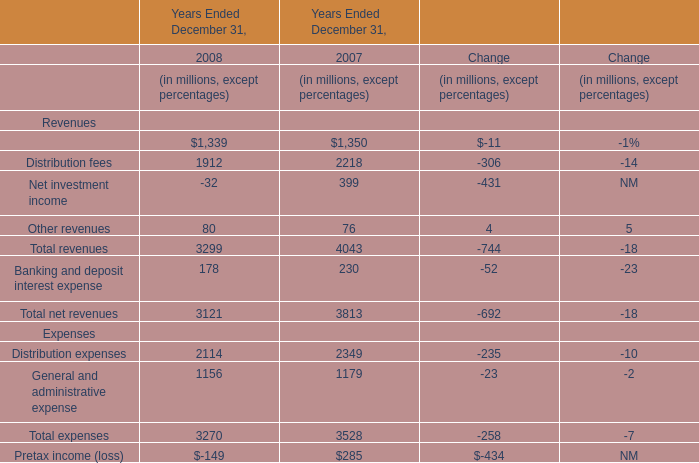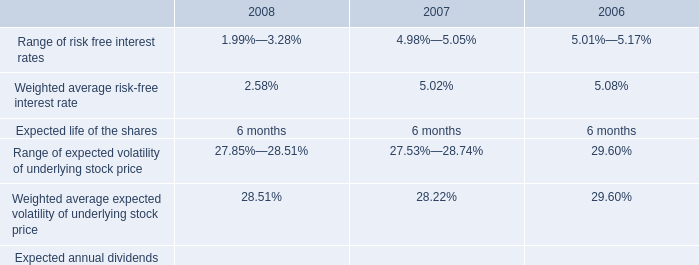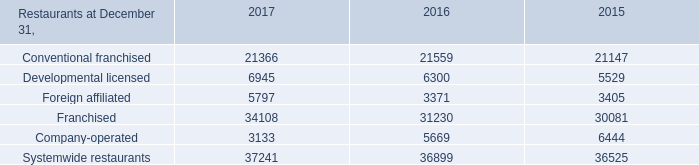What's the average of distribution fees in 2008 and 2007? (in dollars in millions) 
Computations: ((1912 + 2218) / 2)
Answer: 2065.0. 